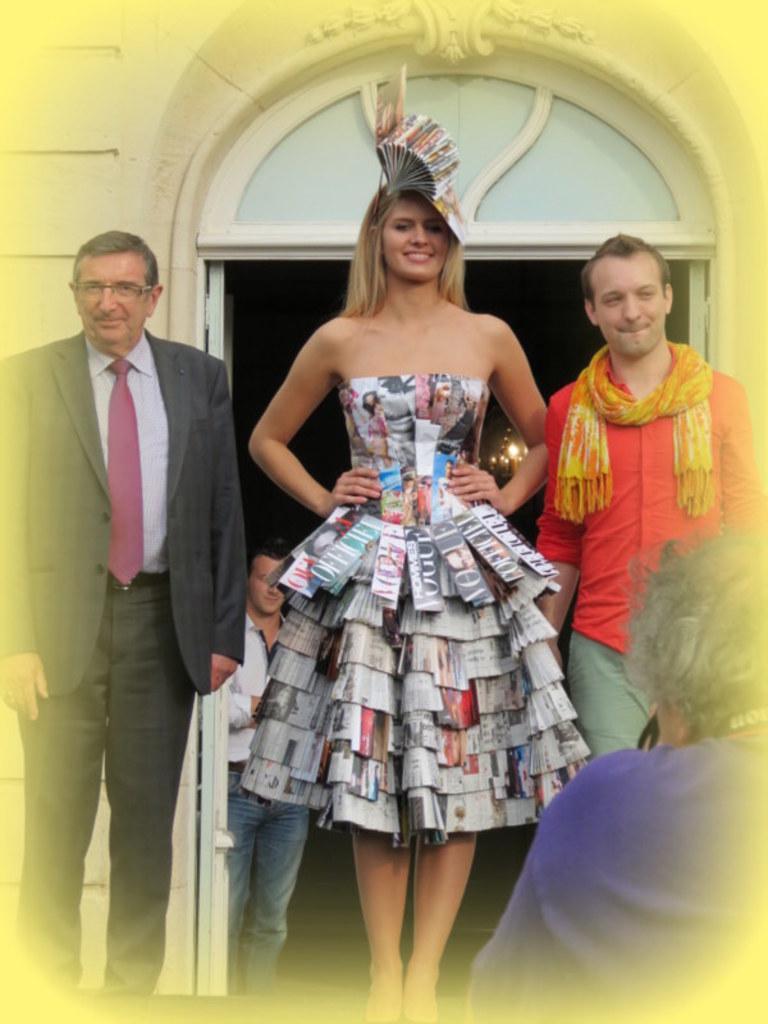Could you give a brief overview of what you see in this image? In the center of the image we can see a lady standing. He is wearing a costume, next to her there is a man wearing a red shirt. In the background there are people. At the bottom we can see a person. On the left there is a man standing. He is wearing a suit. In the background there is a door and a wall. 